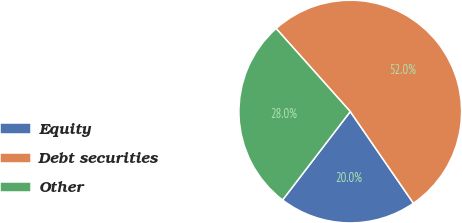Convert chart to OTSL. <chart><loc_0><loc_0><loc_500><loc_500><pie_chart><fcel>Equity<fcel>Debt securities<fcel>Other<nl><fcel>20.0%<fcel>52.0%<fcel>28.0%<nl></chart> 